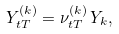<formula> <loc_0><loc_0><loc_500><loc_500>Y ^ { ( k ) } _ { t T } = \nu ^ { ( k ) } _ { t T } \, Y _ { k } ,</formula> 